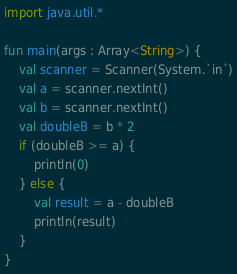<code> <loc_0><loc_0><loc_500><loc_500><_Kotlin_>import java.util.*

fun main(args : Array<String>) {
    val scanner = Scanner(System.`in`)
    val a = scanner.nextInt()
    val b = scanner.nextInt()
    val doubleB = b * 2
    if (doubleB >= a) {
        println(0)
    } else {
        val result = a - doubleB
        println(result)
    }
}</code> 